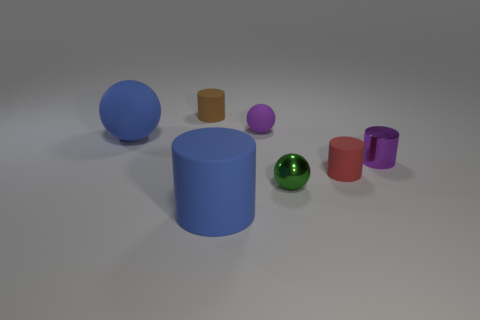Do the tiny brown rubber object and the blue object that is in front of the small red cylinder have the same shape?
Keep it short and to the point. Yes. There is a purple object that is the same shape as the tiny red matte object; what is it made of?
Ensure brevity in your answer.  Metal. What number of big objects are either gray metallic things or spheres?
Your answer should be very brief. 1. Are there fewer green objects to the right of the green metal object than small spheres in front of the blue ball?
Make the answer very short. Yes. How many things are blue rubber cylinders or tiny red matte cylinders?
Make the answer very short. 2. There is a tiny green thing; what number of small red cylinders are to the left of it?
Give a very brief answer. 0. Is the tiny metallic cylinder the same color as the large matte cylinder?
Your answer should be very brief. No. The tiny brown thing that is the same material as the red cylinder is what shape?
Provide a succinct answer. Cylinder. There is a large thing that is behind the large blue cylinder; is its shape the same as the small brown object?
Keep it short and to the point. No. What number of blue things are either tiny objects or rubber cylinders?
Provide a short and direct response. 1. 